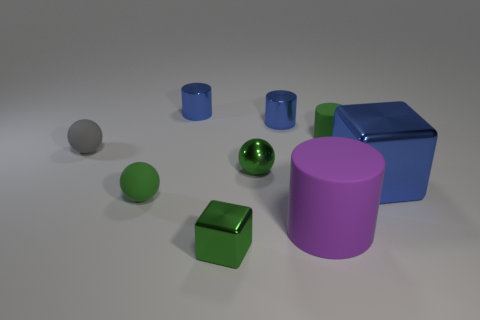Subtract all tiny green cylinders. How many cylinders are left? 3 Subtract all cyan spheres. How many blue cylinders are left? 2 Subtract all green cubes. How many cubes are left? 1 Subtract all cubes. How many objects are left? 7 Add 8 big cubes. How many big cubes exist? 9 Subtract 0 red blocks. How many objects are left? 9 Subtract all blue spheres. Subtract all green cylinders. How many spheres are left? 3 Subtract all big blue cylinders. Subtract all small green rubber cylinders. How many objects are left? 8 Add 2 tiny blue cylinders. How many tiny blue cylinders are left? 4 